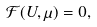Convert formula to latex. <formula><loc_0><loc_0><loc_500><loc_500>\mathcal { F } ( U , \mu ) = 0 ,</formula> 